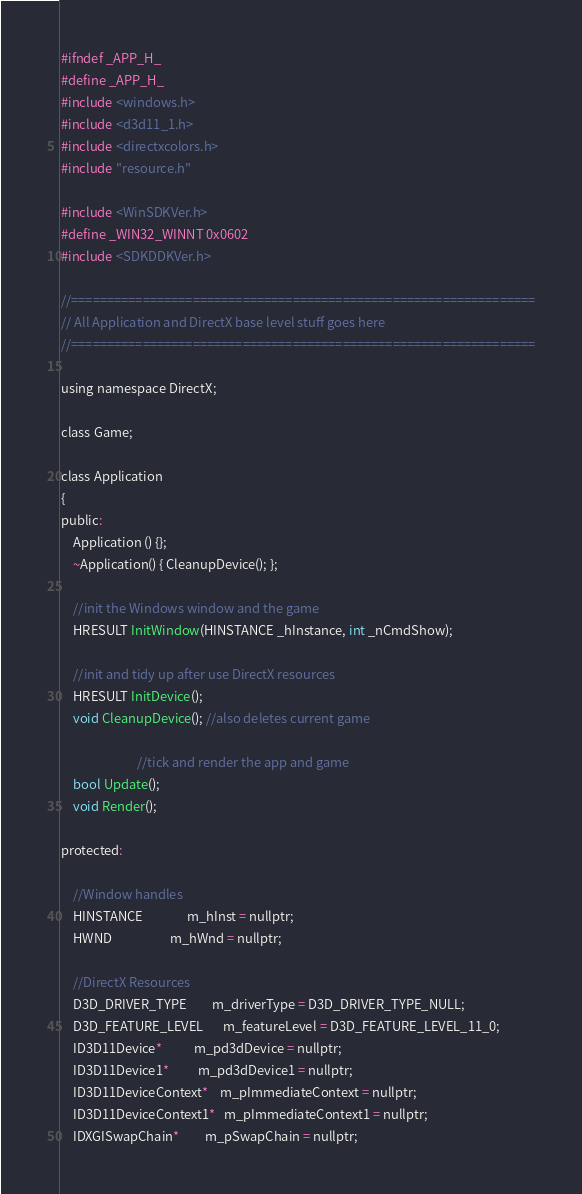<code> <loc_0><loc_0><loc_500><loc_500><_C_>#ifndef _APP_H_
#define _APP_H_
#include <windows.h>
#include <d3d11_1.h>
#include <directxcolors.h>
#include "resource.h"

#include <WinSDKVer.h>
#define _WIN32_WINNT 0x0602
#include <SDKDDKVer.h>

//=================================================================
// All Application and DirectX base level stuff goes here
//=================================================================

using namespace DirectX;

class Game;

class Application
{
public:
	Application () {};
	~Application() { CleanupDevice(); };

	//init the Windows window and the game
	HRESULT InitWindow(HINSTANCE _hInstance, int _nCmdShow);

	//init and tidy up after use DirectX resources
	HRESULT InitDevice();
	void CleanupDevice(); //also deletes current game

						  //tick and render the app and game
	bool Update();
	void Render();

protected:

	//Window handles
	HINSTANCE               m_hInst = nullptr;
	HWND                    m_hWnd = nullptr;

	//DirectX Resources
	D3D_DRIVER_TYPE         m_driverType = D3D_DRIVER_TYPE_NULL;
	D3D_FEATURE_LEVEL       m_featureLevel = D3D_FEATURE_LEVEL_11_0;
	ID3D11Device*           m_pd3dDevice = nullptr;
	ID3D11Device1*          m_pd3dDevice1 = nullptr;
	ID3D11DeviceContext*    m_pImmediateContext = nullptr;
	ID3D11DeviceContext1*   m_pImmediateContext1 = nullptr;
	IDXGISwapChain*         m_pSwapChain = nullptr;</code> 